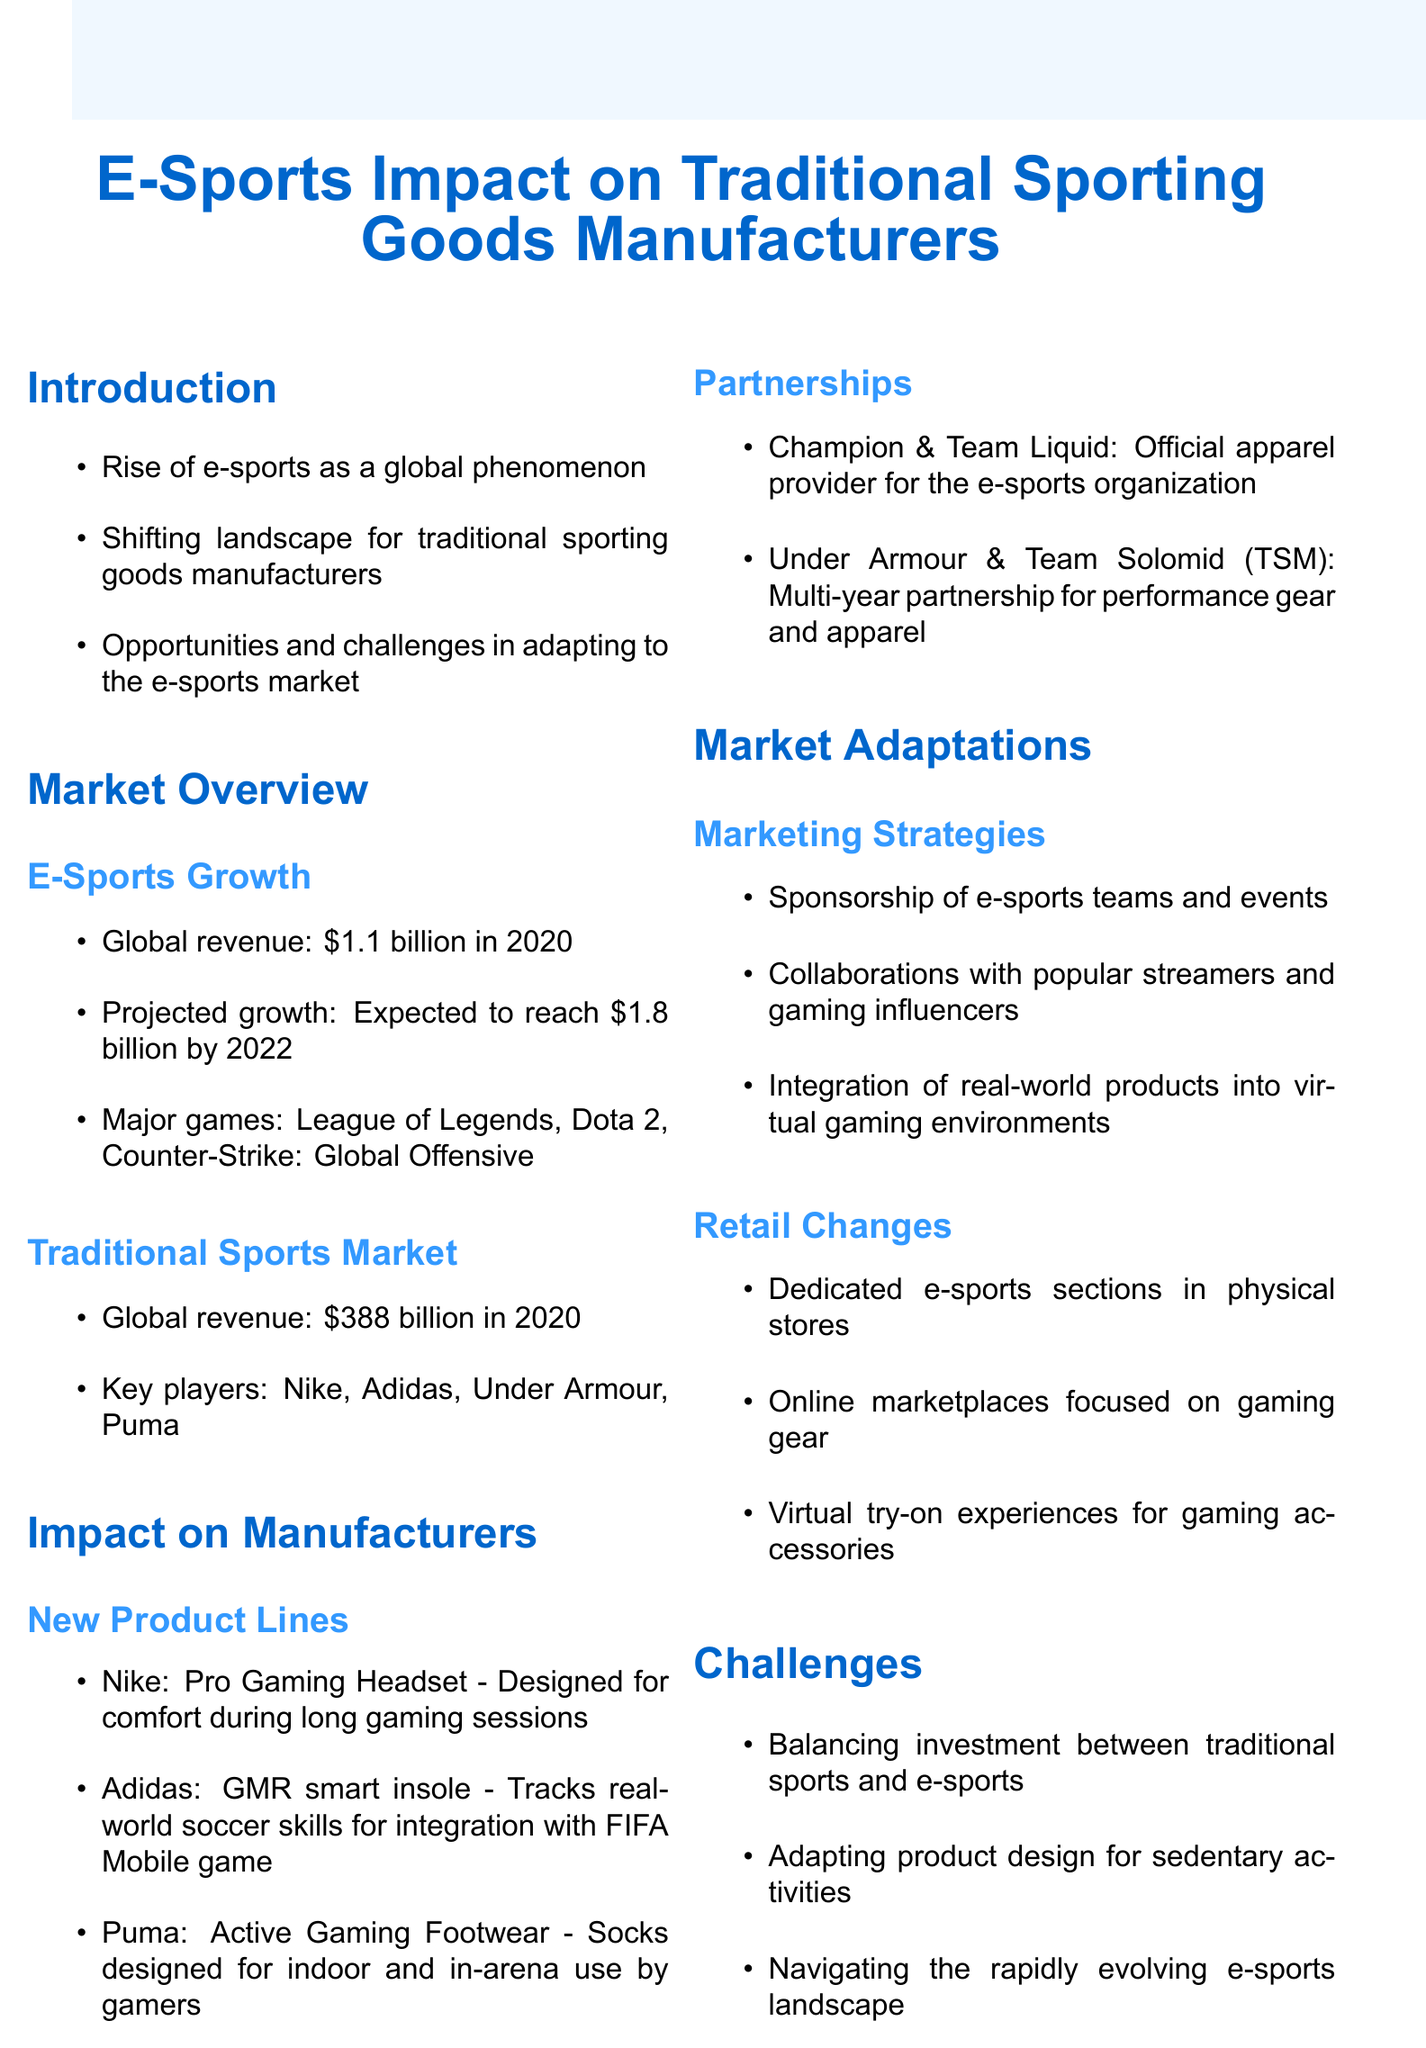what is the global revenue of e-sports in 2020? The document states that the global revenue of e-sports in 2020 is $1.1 billion.
Answer: $1.1 billion what is the projected growth of e-sports by 2022? The document mentions that e-sports is expected to reach $1.8 billion by 2022.
Answer: $1.8 billion which company created the Pro Gaming Headset? The document lists Nike as the company that created the Pro Gaming Headset.
Answer: Nike what are the major games mentioned in the e-sports growth section? The document lists League of Legends, Dota 2, and Counter-Strike: Global Offensive as major games.
Answer: League of Legends, Dota 2, Counter-Strike: Global Offensive what challenge do traditional manufacturers face regarding investment? The document states that manufacturers face the challenge of balancing investment between traditional sports and e-sports.
Answer: balancing investment between traditional sports and e-sports what type of marketing strategy includes collaborations with influencers? Collaborations with popular streamers and gaming influencers are part of the marketing strategies mentioned in the document.
Answer: collaborations with popular streamers and gaming influencers how many new product lines are listed under the impact on manufacturers? There are three new product lines listed in the document under the impact on manufacturers.
Answer: three what is one opportunity mentioned for traditional sporting goods manufacturers? The document mentions the expansion into e-sports performance wear as an opportunity.
Answer: expansion into e-sports performance wear which company partnered with Team Solomid (TSM)? Under Armour is indicated in the document as the company that partnered with Team Solomid (TSM).
Answer: Under Armour 